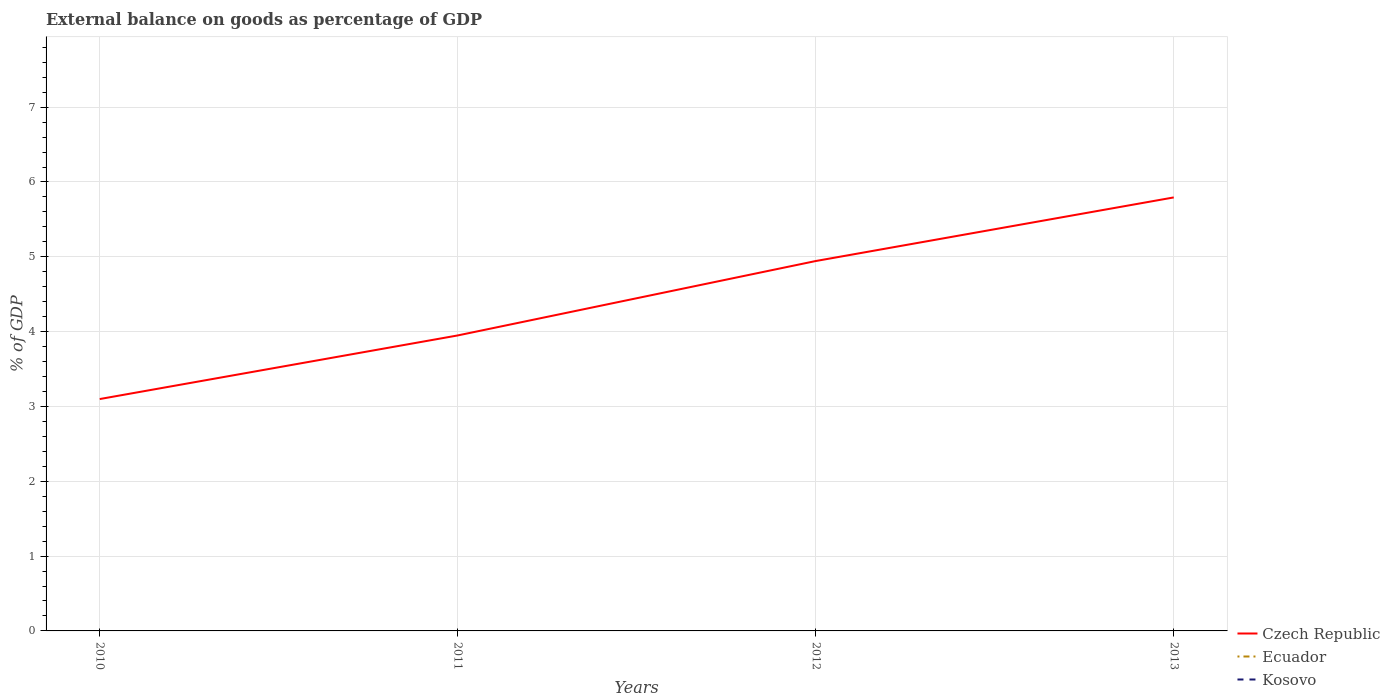Is the number of lines equal to the number of legend labels?
Your answer should be very brief. No. Across all years, what is the maximum external balance on goods as percentage of GDP in Ecuador?
Offer a terse response. 0. What is the total external balance on goods as percentage of GDP in Czech Republic in the graph?
Offer a very short reply. -2.69. What is the difference between the highest and the second highest external balance on goods as percentage of GDP in Czech Republic?
Make the answer very short. 2.69. What is the difference between the highest and the lowest external balance on goods as percentage of GDP in Czech Republic?
Make the answer very short. 2. How many lines are there?
Your answer should be very brief. 1. Are the values on the major ticks of Y-axis written in scientific E-notation?
Your answer should be compact. No. Does the graph contain any zero values?
Make the answer very short. Yes. Does the graph contain grids?
Make the answer very short. Yes. How are the legend labels stacked?
Give a very brief answer. Vertical. What is the title of the graph?
Your response must be concise. External balance on goods as percentage of GDP. Does "Monaco" appear as one of the legend labels in the graph?
Make the answer very short. No. What is the label or title of the X-axis?
Make the answer very short. Years. What is the label or title of the Y-axis?
Ensure brevity in your answer.  % of GDP. What is the % of GDP in Czech Republic in 2010?
Give a very brief answer. 3.1. What is the % of GDP in Ecuador in 2010?
Provide a succinct answer. 0. What is the % of GDP in Czech Republic in 2011?
Your answer should be compact. 3.95. What is the % of GDP in Ecuador in 2011?
Make the answer very short. 0. What is the % of GDP in Czech Republic in 2012?
Give a very brief answer. 4.94. What is the % of GDP of Ecuador in 2012?
Ensure brevity in your answer.  0. What is the % of GDP of Czech Republic in 2013?
Your answer should be compact. 5.79. What is the % of GDP of Ecuador in 2013?
Keep it short and to the point. 0. What is the % of GDP in Kosovo in 2013?
Your answer should be very brief. 0. Across all years, what is the maximum % of GDP in Czech Republic?
Make the answer very short. 5.79. Across all years, what is the minimum % of GDP of Czech Republic?
Your response must be concise. 3.1. What is the total % of GDP of Czech Republic in the graph?
Your response must be concise. 17.78. What is the total % of GDP in Ecuador in the graph?
Provide a succinct answer. 0. What is the difference between the % of GDP of Czech Republic in 2010 and that in 2011?
Provide a short and direct response. -0.85. What is the difference between the % of GDP of Czech Republic in 2010 and that in 2012?
Offer a very short reply. -1.84. What is the difference between the % of GDP of Czech Republic in 2010 and that in 2013?
Provide a succinct answer. -2.69. What is the difference between the % of GDP in Czech Republic in 2011 and that in 2012?
Offer a terse response. -0.99. What is the difference between the % of GDP in Czech Republic in 2011 and that in 2013?
Offer a very short reply. -1.84. What is the difference between the % of GDP in Czech Republic in 2012 and that in 2013?
Keep it short and to the point. -0.85. What is the average % of GDP in Czech Republic per year?
Offer a very short reply. 4.45. What is the average % of GDP in Ecuador per year?
Your response must be concise. 0. What is the ratio of the % of GDP in Czech Republic in 2010 to that in 2011?
Provide a short and direct response. 0.78. What is the ratio of the % of GDP of Czech Republic in 2010 to that in 2012?
Offer a terse response. 0.63. What is the ratio of the % of GDP of Czech Republic in 2010 to that in 2013?
Your answer should be compact. 0.53. What is the ratio of the % of GDP in Czech Republic in 2011 to that in 2012?
Make the answer very short. 0.8. What is the ratio of the % of GDP in Czech Republic in 2011 to that in 2013?
Your answer should be very brief. 0.68. What is the ratio of the % of GDP in Czech Republic in 2012 to that in 2013?
Offer a very short reply. 0.85. What is the difference between the highest and the lowest % of GDP of Czech Republic?
Provide a short and direct response. 2.69. 